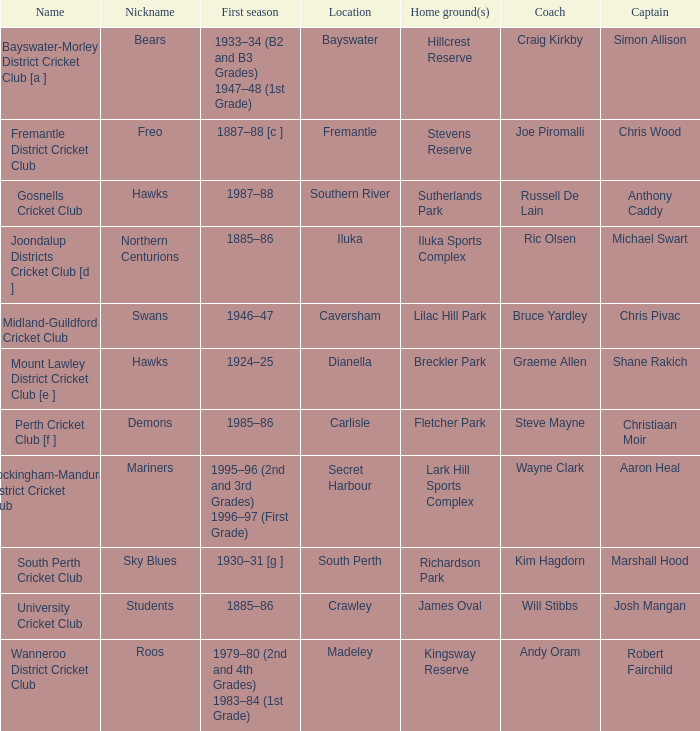What are the dates when hillcrest reserve serves as the home grounds? 1933–34 (B2 and B3 Grades) 1947–48 (1st Grade). 